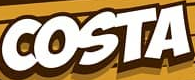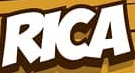Identify the words shown in these images in order, separated by a semicolon. COSTA; RICA 